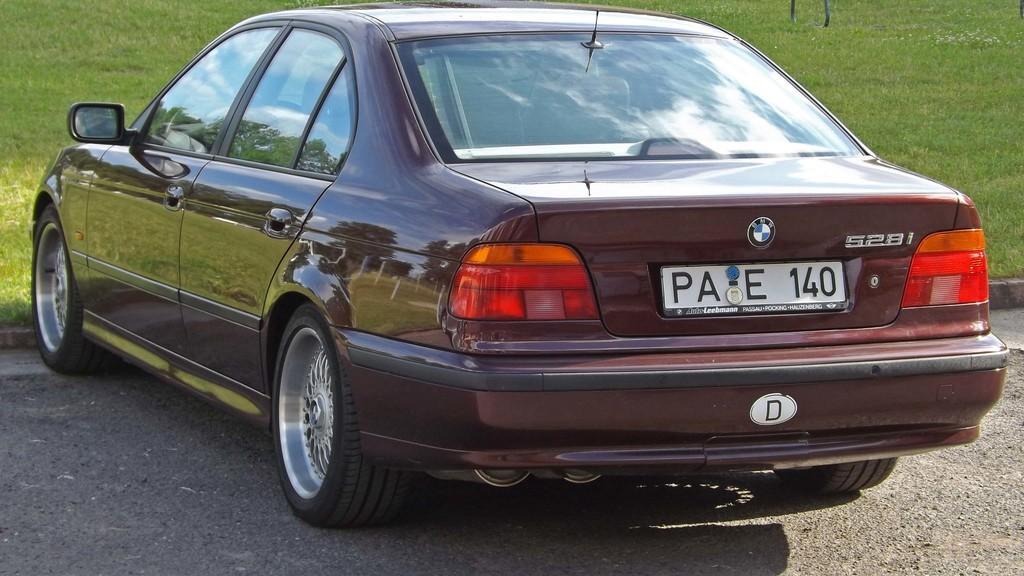Can you describe this image briefly? In this image we can see a car. In the background there is a grass. 